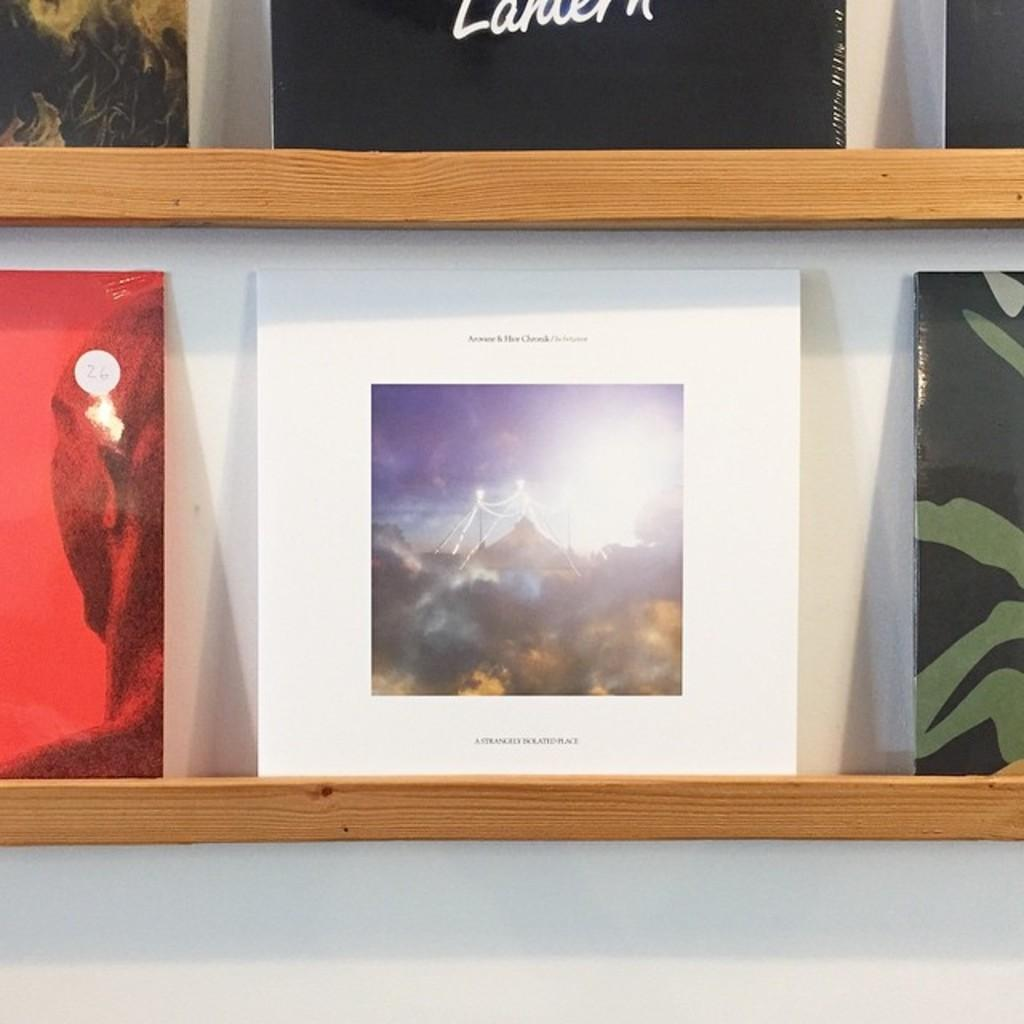Provide a one-sentence caption for the provided image. Two thin wooded book shelves holding an assortment of books with a white bordered book on prominent display. 